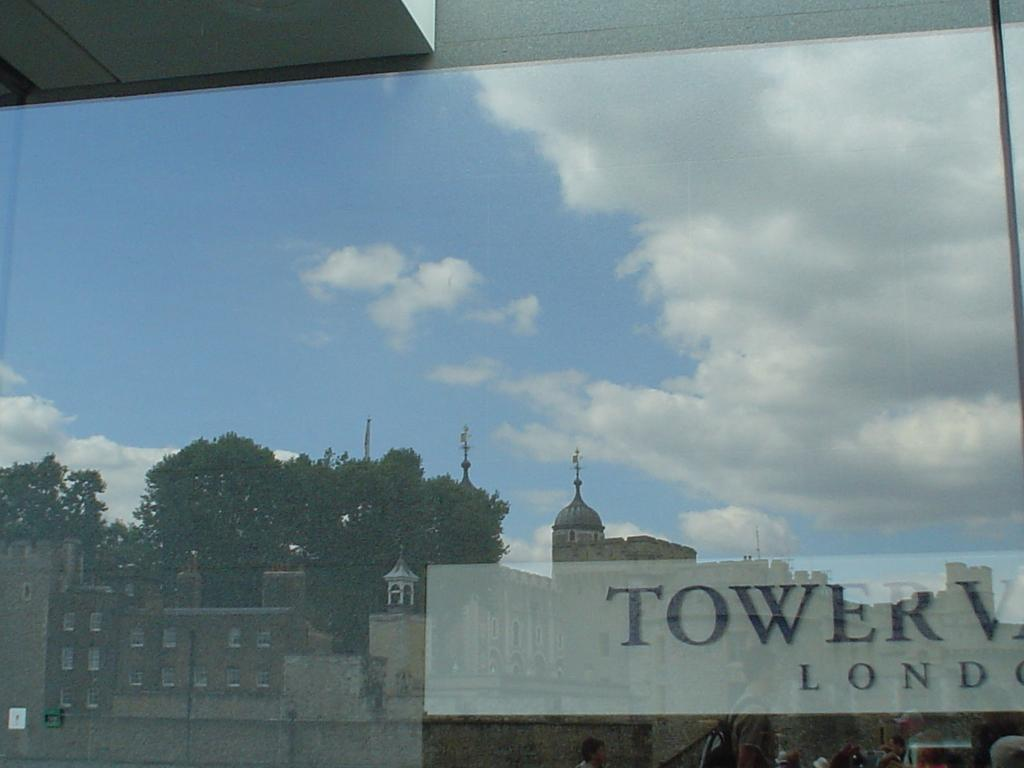<image>
Write a terse but informative summary of the picture. A large sign identifies a London location with the word Tower in the name. 